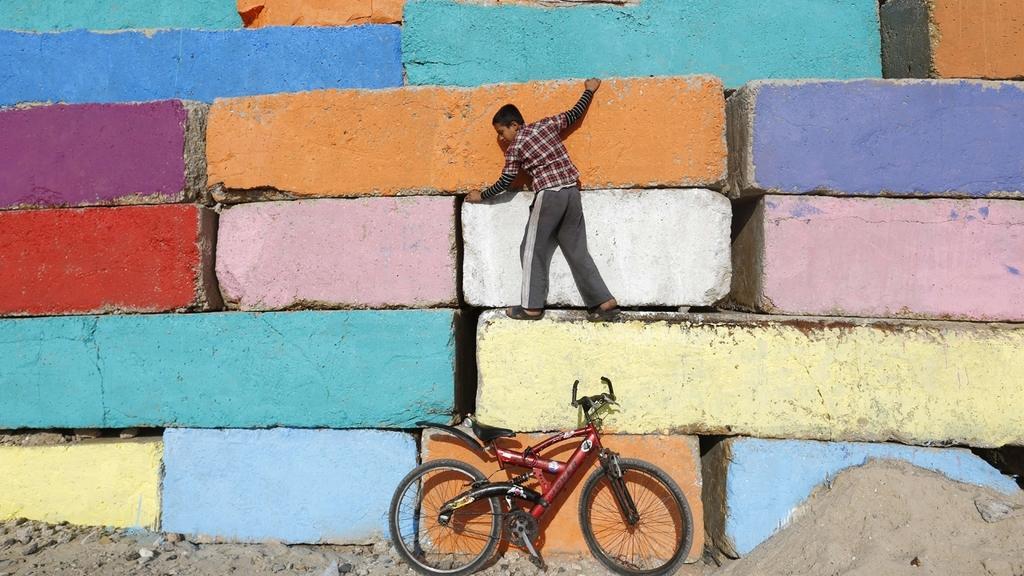In one or two sentences, can you explain what this image depicts? In the center of the image there is a wall. There is a boy on the wall. At the bottom of the image there is bicycle. There is sand. There are stones. 